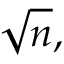Convert formula to latex. <formula><loc_0><loc_0><loc_500><loc_500>{ \sqrt { n } } ,</formula> 